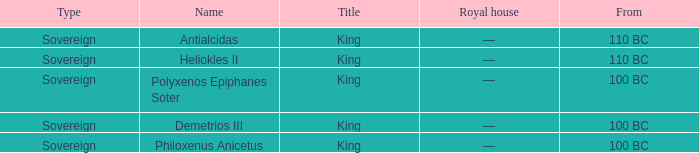When did Demetrios III begin to hold power? 100 BC. 